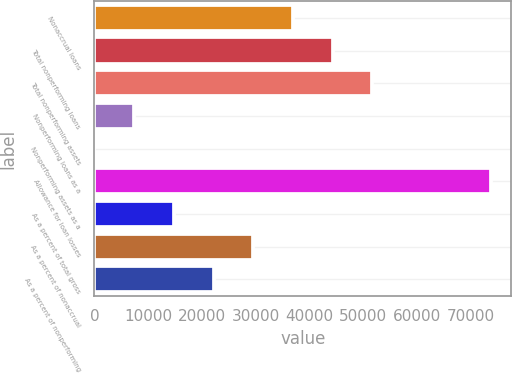<chart> <loc_0><loc_0><loc_500><loc_500><bar_chart><fcel>Nonaccrual loans<fcel>Total nonperforming loans<fcel>Total nonperforming assets<fcel>Nonperforming loans as a<fcel>Nonperforming assets as a<fcel>Allowance for loan losses<fcel>As a percent of total gross<fcel>As a percent of nonaccrual<fcel>As a percent of nonperforming<nl><fcel>36900.2<fcel>44280.1<fcel>51660.1<fcel>7380.27<fcel>0.3<fcel>73800<fcel>14760.2<fcel>29520.2<fcel>22140.2<nl></chart> 